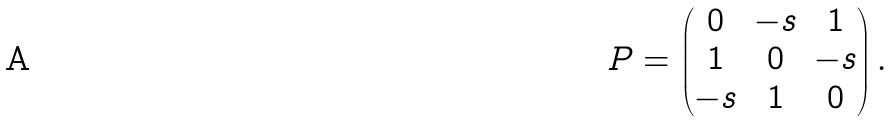Convert formula to latex. <formula><loc_0><loc_0><loc_500><loc_500>P = \begin{pmatrix} 0 & - s & 1 \\ 1 & 0 & - s \\ - s & 1 & 0 \end{pmatrix} .</formula> 